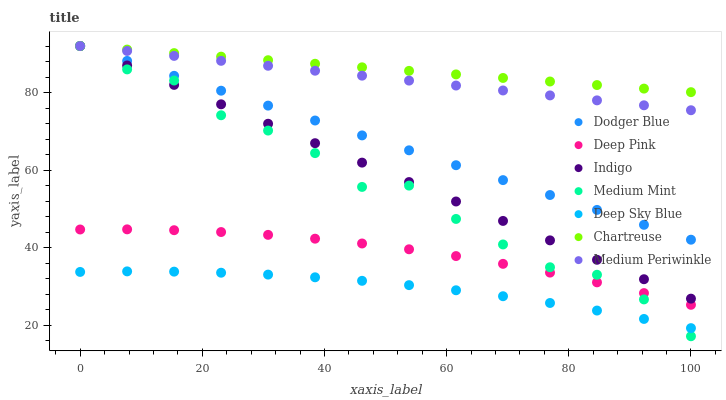Does Deep Sky Blue have the minimum area under the curve?
Answer yes or no. Yes. Does Chartreuse have the maximum area under the curve?
Answer yes or no. Yes. Does Deep Pink have the minimum area under the curve?
Answer yes or no. No. Does Deep Pink have the maximum area under the curve?
Answer yes or no. No. Is Indigo the smoothest?
Answer yes or no. Yes. Is Medium Mint the roughest?
Answer yes or no. Yes. Is Deep Pink the smoothest?
Answer yes or no. No. Is Deep Pink the roughest?
Answer yes or no. No. Does Medium Mint have the lowest value?
Answer yes or no. Yes. Does Deep Pink have the lowest value?
Answer yes or no. No. Does Dodger Blue have the highest value?
Answer yes or no. Yes. Does Deep Pink have the highest value?
Answer yes or no. No. Is Deep Pink less than Indigo?
Answer yes or no. Yes. Is Dodger Blue greater than Deep Pink?
Answer yes or no. Yes. Does Medium Mint intersect Indigo?
Answer yes or no. Yes. Is Medium Mint less than Indigo?
Answer yes or no. No. Is Medium Mint greater than Indigo?
Answer yes or no. No. Does Deep Pink intersect Indigo?
Answer yes or no. No. 